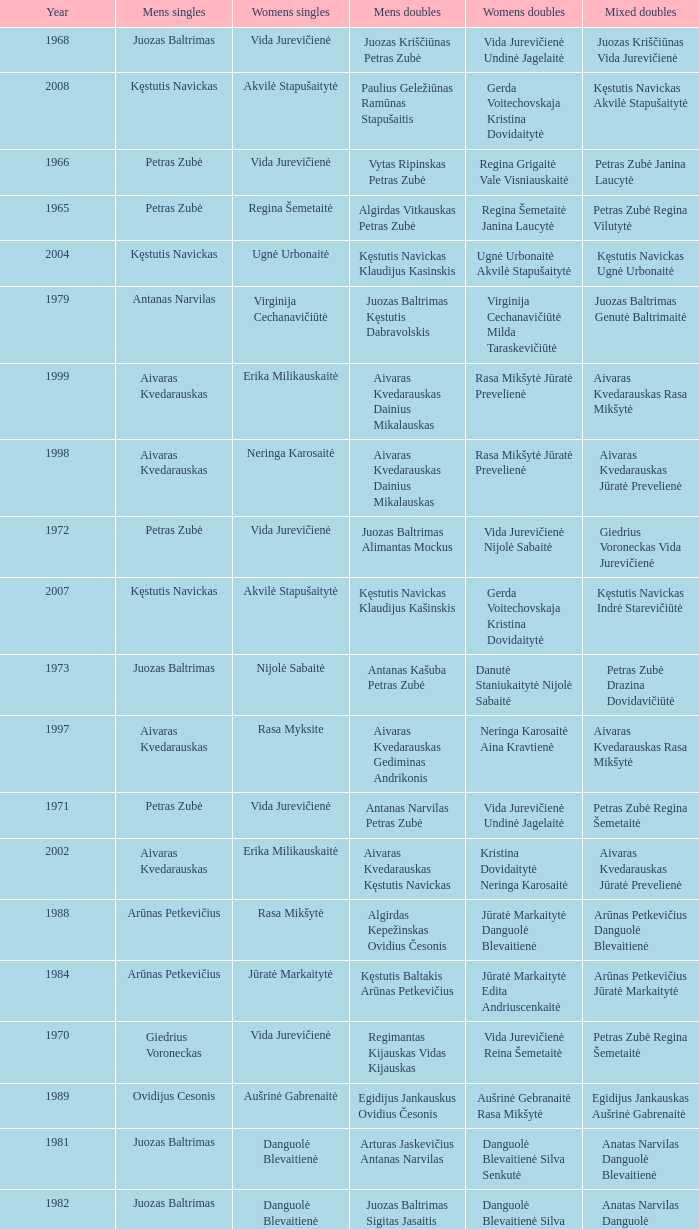What was the first year of the Lithuanian National Badminton Championships? 1963.0. 